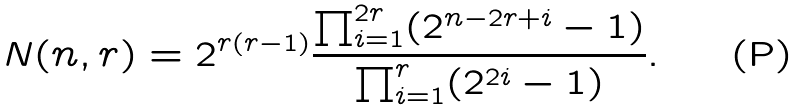Convert formula to latex. <formula><loc_0><loc_0><loc_500><loc_500>N ( n , r ) = 2 ^ { r ( r - 1 ) } \frac { \prod _ { i = 1 } ^ { 2 r } ( 2 ^ { n - 2 r + i } - 1 ) } { \prod _ { i = 1 } ^ { r } ( 2 ^ { 2 i } - 1 ) } .</formula> 